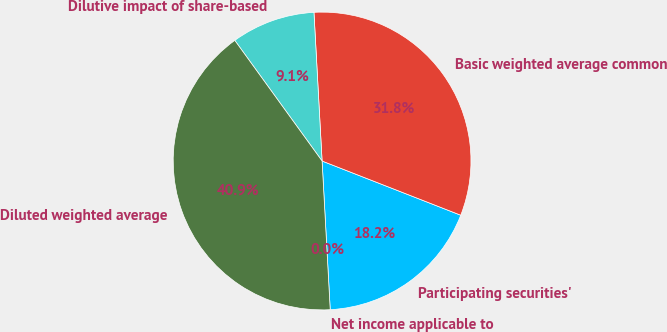<chart> <loc_0><loc_0><loc_500><loc_500><pie_chart><fcel>Net income applicable to<fcel>Participating securities'<fcel>Basic weighted average common<fcel>Dilutive impact of share-based<fcel>Diluted weighted average<nl><fcel>0.0%<fcel>18.2%<fcel>31.8%<fcel>9.1%<fcel>40.9%<nl></chart> 